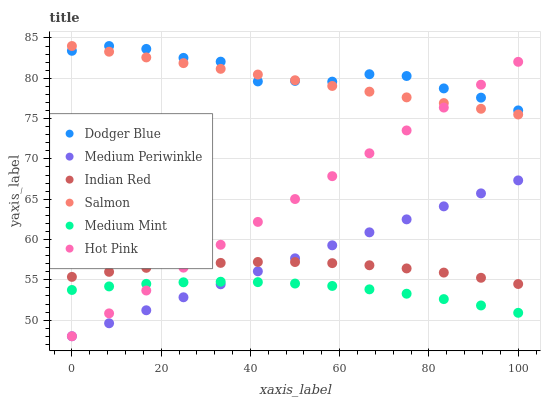Does Medium Mint have the minimum area under the curve?
Answer yes or no. Yes. Does Dodger Blue have the maximum area under the curve?
Answer yes or no. Yes. Does Salmon have the minimum area under the curve?
Answer yes or no. No. Does Salmon have the maximum area under the curve?
Answer yes or no. No. Is Salmon the smoothest?
Answer yes or no. Yes. Is Dodger Blue the roughest?
Answer yes or no. Yes. Is Hot Pink the smoothest?
Answer yes or no. No. Is Hot Pink the roughest?
Answer yes or no. No. Does Hot Pink have the lowest value?
Answer yes or no. Yes. Does Salmon have the lowest value?
Answer yes or no. No. Does Dodger Blue have the highest value?
Answer yes or no. Yes. Does Hot Pink have the highest value?
Answer yes or no. No. Is Indian Red less than Dodger Blue?
Answer yes or no. Yes. Is Dodger Blue greater than Indian Red?
Answer yes or no. Yes. Does Medium Mint intersect Hot Pink?
Answer yes or no. Yes. Is Medium Mint less than Hot Pink?
Answer yes or no. No. Is Medium Mint greater than Hot Pink?
Answer yes or no. No. Does Indian Red intersect Dodger Blue?
Answer yes or no. No. 